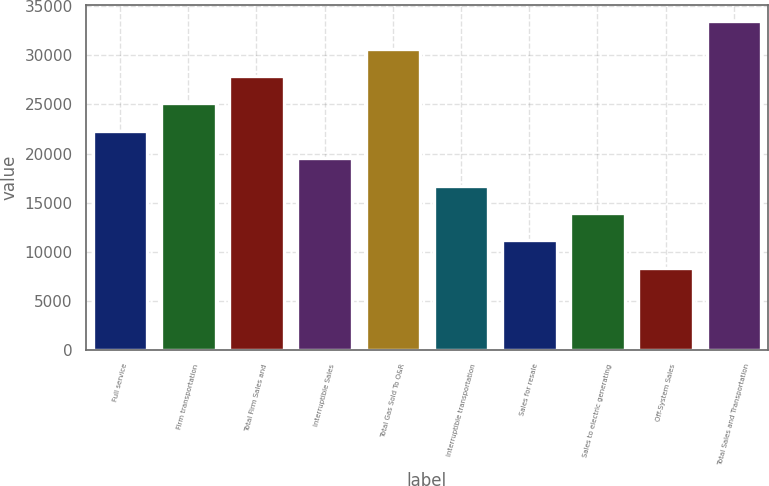Convert chart. <chart><loc_0><loc_0><loc_500><loc_500><bar_chart><fcel>Full service<fcel>Firm transportation<fcel>Total Firm Sales and<fcel>Interruptible Sales<fcel>Total Gas Sold To O&R<fcel>Interruptible transportation<fcel>Sales for resale<fcel>Sales to electric generating<fcel>Off-System Sales<fcel>Total Sales and Transportation<nl><fcel>22314.6<fcel>25102.8<fcel>27891<fcel>19526.4<fcel>30679.2<fcel>16738.2<fcel>11161.8<fcel>13950<fcel>8373.6<fcel>33467.4<nl></chart> 